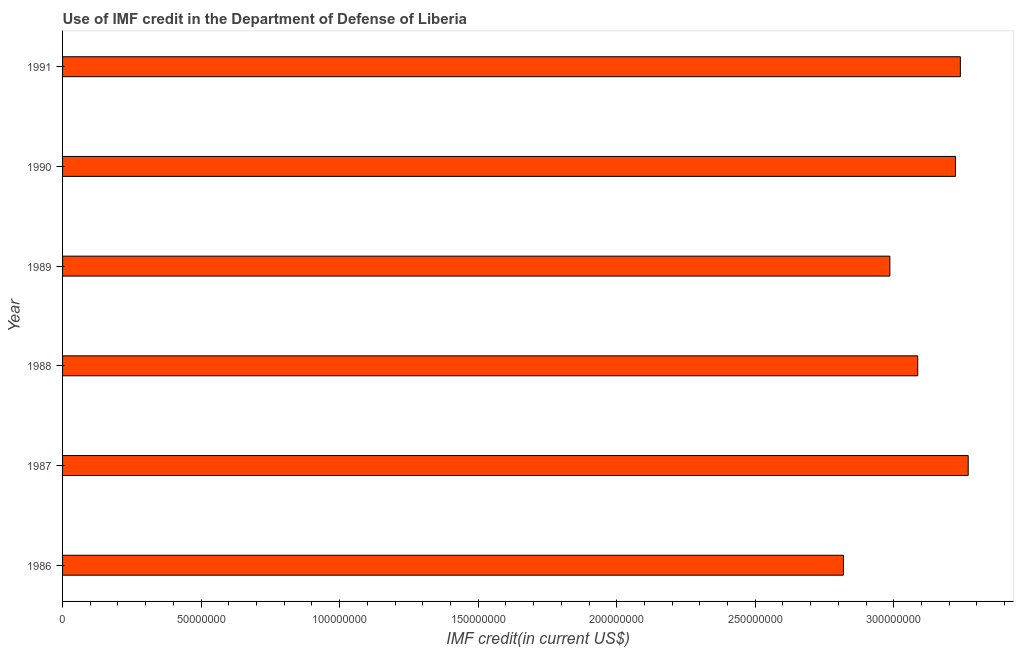Does the graph contain any zero values?
Offer a terse response. No. What is the title of the graph?
Provide a short and direct response. Use of IMF credit in the Department of Defense of Liberia. What is the label or title of the X-axis?
Offer a very short reply. IMF credit(in current US$). What is the label or title of the Y-axis?
Your response must be concise. Year. What is the use of imf credit in dod in 1989?
Your answer should be very brief. 2.99e+08. Across all years, what is the maximum use of imf credit in dod?
Make the answer very short. 3.27e+08. Across all years, what is the minimum use of imf credit in dod?
Give a very brief answer. 2.82e+08. What is the sum of the use of imf credit in dod?
Provide a succinct answer. 1.86e+09. What is the difference between the use of imf credit in dod in 1986 and 1988?
Ensure brevity in your answer.  -2.68e+07. What is the average use of imf credit in dod per year?
Ensure brevity in your answer.  3.10e+08. What is the median use of imf credit in dod?
Your response must be concise. 3.15e+08. What is the ratio of the use of imf credit in dod in 1990 to that in 1991?
Your answer should be compact. 0.99. What is the difference between the highest and the second highest use of imf credit in dod?
Provide a succinct answer. 2.83e+06. What is the difference between the highest and the lowest use of imf credit in dod?
Ensure brevity in your answer.  4.50e+07. In how many years, is the use of imf credit in dod greater than the average use of imf credit in dod taken over all years?
Make the answer very short. 3. Are the values on the major ticks of X-axis written in scientific E-notation?
Give a very brief answer. No. What is the IMF credit(in current US$) of 1986?
Offer a very short reply. 2.82e+08. What is the IMF credit(in current US$) of 1987?
Your answer should be very brief. 3.27e+08. What is the IMF credit(in current US$) in 1988?
Your response must be concise. 3.09e+08. What is the IMF credit(in current US$) in 1989?
Make the answer very short. 2.99e+08. What is the IMF credit(in current US$) in 1990?
Provide a short and direct response. 3.22e+08. What is the IMF credit(in current US$) of 1991?
Make the answer very short. 3.24e+08. What is the difference between the IMF credit(in current US$) in 1986 and 1987?
Keep it short and to the point. -4.50e+07. What is the difference between the IMF credit(in current US$) in 1986 and 1988?
Offer a terse response. -2.68e+07. What is the difference between the IMF credit(in current US$) in 1986 and 1989?
Offer a terse response. -1.68e+07. What is the difference between the IMF credit(in current US$) in 1986 and 1990?
Keep it short and to the point. -4.04e+07. What is the difference between the IMF credit(in current US$) in 1986 and 1991?
Make the answer very short. -4.22e+07. What is the difference between the IMF credit(in current US$) in 1987 and 1988?
Provide a short and direct response. 1.82e+07. What is the difference between the IMF credit(in current US$) in 1987 and 1989?
Offer a terse response. 2.83e+07. What is the difference between the IMF credit(in current US$) in 1987 and 1990?
Provide a succinct answer. 4.59e+06. What is the difference between the IMF credit(in current US$) in 1987 and 1991?
Your response must be concise. 2.83e+06. What is the difference between the IMF credit(in current US$) in 1988 and 1989?
Make the answer very short. 1.01e+07. What is the difference between the IMF credit(in current US$) in 1988 and 1990?
Your response must be concise. -1.36e+07. What is the difference between the IMF credit(in current US$) in 1988 and 1991?
Your answer should be compact. -1.54e+07. What is the difference between the IMF credit(in current US$) in 1989 and 1990?
Offer a very short reply. -2.37e+07. What is the difference between the IMF credit(in current US$) in 1989 and 1991?
Provide a short and direct response. -2.54e+07. What is the difference between the IMF credit(in current US$) in 1990 and 1991?
Provide a succinct answer. -1.76e+06. What is the ratio of the IMF credit(in current US$) in 1986 to that in 1987?
Ensure brevity in your answer.  0.86. What is the ratio of the IMF credit(in current US$) in 1986 to that in 1989?
Your answer should be compact. 0.94. What is the ratio of the IMF credit(in current US$) in 1986 to that in 1990?
Offer a very short reply. 0.88. What is the ratio of the IMF credit(in current US$) in 1986 to that in 1991?
Ensure brevity in your answer.  0.87. What is the ratio of the IMF credit(in current US$) in 1987 to that in 1988?
Your answer should be compact. 1.06. What is the ratio of the IMF credit(in current US$) in 1987 to that in 1989?
Keep it short and to the point. 1.09. What is the ratio of the IMF credit(in current US$) in 1987 to that in 1990?
Give a very brief answer. 1.01. What is the ratio of the IMF credit(in current US$) in 1988 to that in 1989?
Ensure brevity in your answer.  1.03. What is the ratio of the IMF credit(in current US$) in 1988 to that in 1990?
Offer a terse response. 0.96. What is the ratio of the IMF credit(in current US$) in 1988 to that in 1991?
Ensure brevity in your answer.  0.95. What is the ratio of the IMF credit(in current US$) in 1989 to that in 1990?
Your answer should be very brief. 0.93. What is the ratio of the IMF credit(in current US$) in 1989 to that in 1991?
Ensure brevity in your answer.  0.92. What is the ratio of the IMF credit(in current US$) in 1990 to that in 1991?
Offer a very short reply. 0.99. 